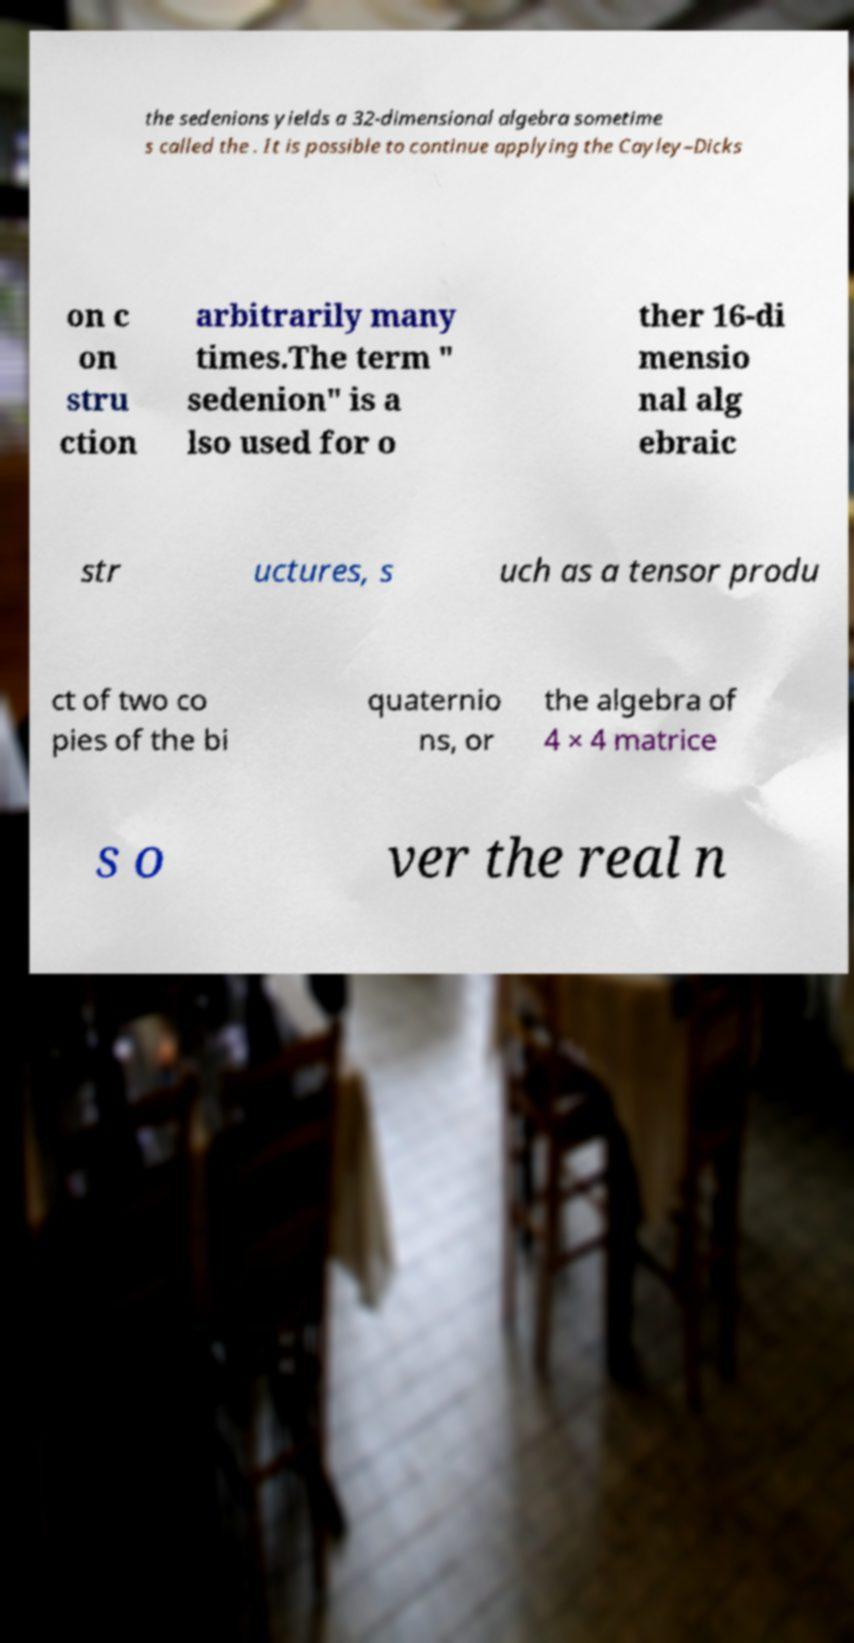Could you extract and type out the text from this image? the sedenions yields a 32-dimensional algebra sometime s called the . It is possible to continue applying the Cayley–Dicks on c on stru ction arbitrarily many times.The term " sedenion" is a lso used for o ther 16-di mensio nal alg ebraic str uctures, s uch as a tensor produ ct of two co pies of the bi quaternio ns, or the algebra of 4 × 4 matrice s o ver the real n 